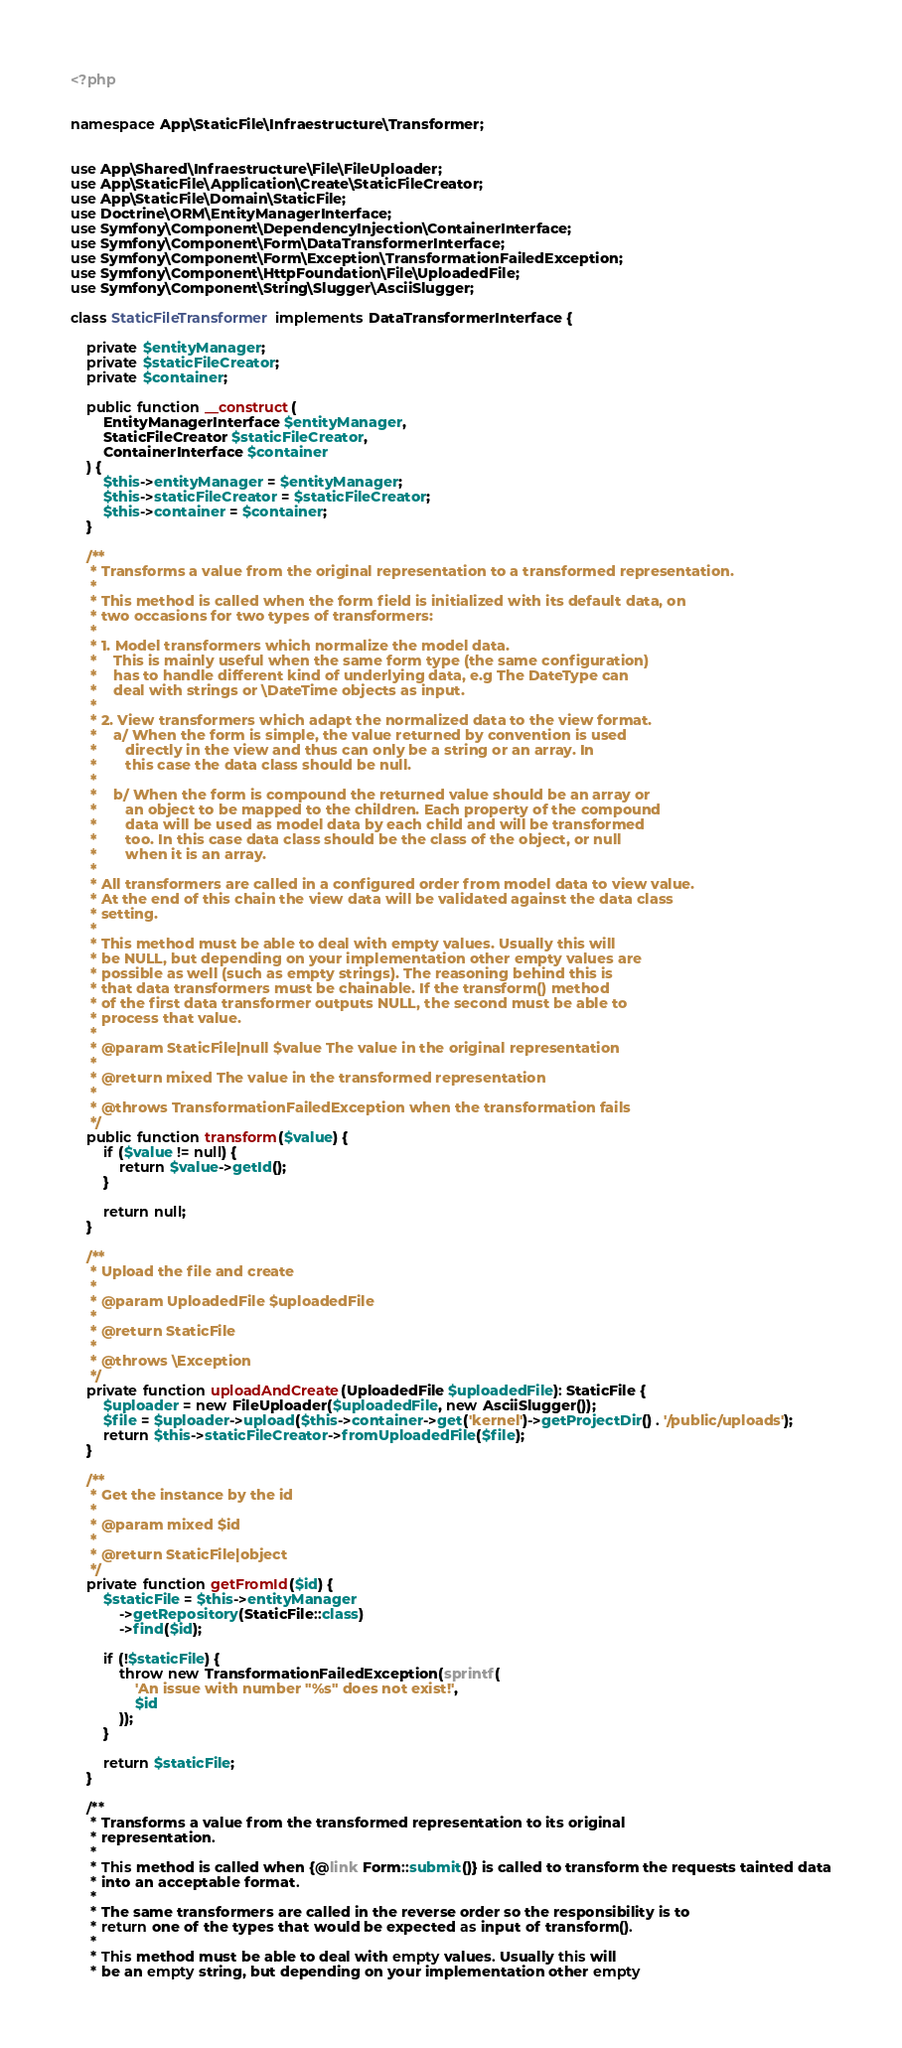Convert code to text. <code><loc_0><loc_0><loc_500><loc_500><_PHP_><?php


namespace App\StaticFile\Infraestructure\Transformer;


use App\Shared\Infraestructure\File\FileUploader;
use App\StaticFile\Application\Create\StaticFileCreator;
use App\StaticFile\Domain\StaticFile;
use Doctrine\ORM\EntityManagerInterface;
use Symfony\Component\DependencyInjection\ContainerInterface;
use Symfony\Component\Form\DataTransformerInterface;
use Symfony\Component\Form\Exception\TransformationFailedException;
use Symfony\Component\HttpFoundation\File\UploadedFile;
use Symfony\Component\String\Slugger\AsciiSlugger;

class StaticFileTransformer implements DataTransformerInterface {

    private $entityManager;
    private $staticFileCreator;
    private $container;

    public function __construct(
        EntityManagerInterface $entityManager,
        StaticFileCreator $staticFileCreator,
        ContainerInterface $container
    ) {
        $this->entityManager = $entityManager;
        $this->staticFileCreator = $staticFileCreator;
        $this->container = $container;
    }

    /**
     * Transforms a value from the original representation to a transformed representation.
     *
     * This method is called when the form field is initialized with its default data, on
     * two occasions for two types of transformers:
     *
     * 1. Model transformers which normalize the model data.
     *    This is mainly useful when the same form type (the same configuration)
     *    has to handle different kind of underlying data, e.g The DateType can
     *    deal with strings or \DateTime objects as input.
     *
     * 2. View transformers which adapt the normalized data to the view format.
     *    a/ When the form is simple, the value returned by convention is used
     *       directly in the view and thus can only be a string or an array. In
     *       this case the data class should be null.
     *
     *    b/ When the form is compound the returned value should be an array or
     *       an object to be mapped to the children. Each property of the compound
     *       data will be used as model data by each child and will be transformed
     *       too. In this case data class should be the class of the object, or null
     *       when it is an array.
     *
     * All transformers are called in a configured order from model data to view value.
     * At the end of this chain the view data will be validated against the data class
     * setting.
     *
     * This method must be able to deal with empty values. Usually this will
     * be NULL, but depending on your implementation other empty values are
     * possible as well (such as empty strings). The reasoning behind this is
     * that data transformers must be chainable. If the transform() method
     * of the first data transformer outputs NULL, the second must be able to
     * process that value.
     *
     * @param StaticFile|null $value The value in the original representation
     *
     * @return mixed The value in the transformed representation
     *
     * @throws TransformationFailedException when the transformation fails
     */
    public function transform($value) {
        if ($value != null) {
            return $value->getId();
        }

        return null;
    }

    /**
     * Upload the file and create
     *
     * @param UploadedFile $uploadedFile
     *
     * @return StaticFile
     *
     * @throws \Exception
     */
    private function uploadAndCreate(UploadedFile $uploadedFile): StaticFile {
        $uploader = new FileUploader($uploadedFile, new AsciiSlugger());
        $file = $uploader->upload($this->container->get('kernel')->getProjectDir() . '/public/uploads');
        return $this->staticFileCreator->fromUploadedFile($file);
    }

    /**
     * Get the instance by the id
     *
     * @param mixed $id
     *
     * @return StaticFile|object
     */
    private function getFromId($id) {
        $staticFile = $this->entityManager
            ->getRepository(StaticFile::class)
            ->find($id);

        if (!$staticFile) {
            throw new TransformationFailedException(sprintf(
                'An issue with number "%s" does not exist!',
                $id
            ));
        }

        return $staticFile;
    }

    /**
     * Transforms a value from the transformed representation to its original
     * representation.
     *
     * This method is called when {@link Form::submit()} is called to transform the requests tainted data
     * into an acceptable format.
     *
     * The same transformers are called in the reverse order so the responsibility is to
     * return one of the types that would be expected as input of transform().
     *
     * This method must be able to deal with empty values. Usually this will
     * be an empty string, but depending on your implementation other empty</code> 